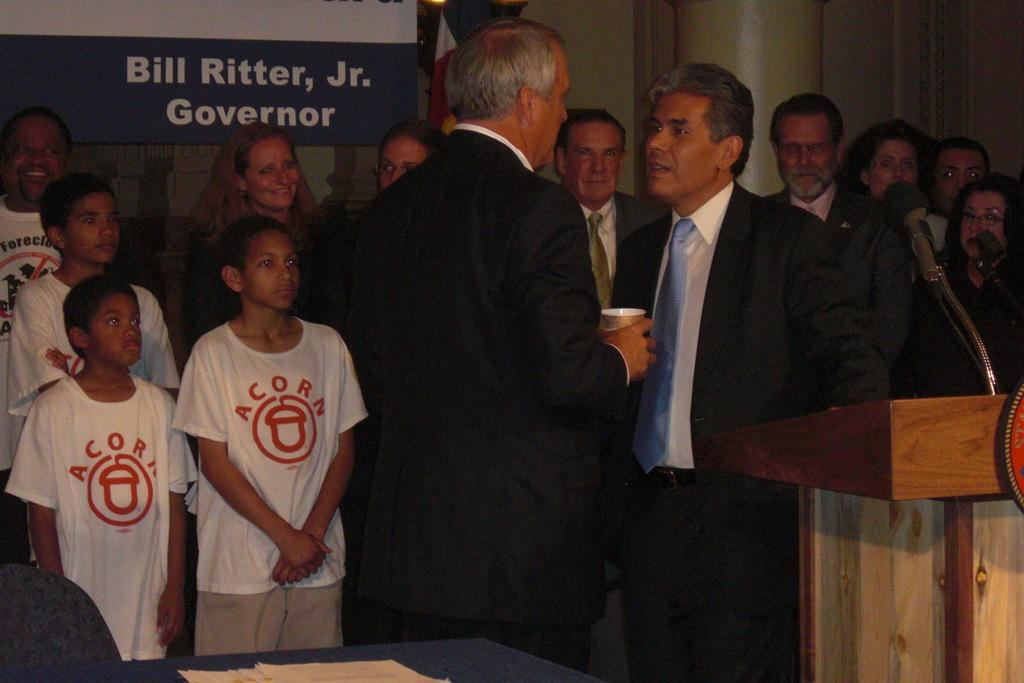<image>
Provide a brief description of the given image. Two men talking in front of a group of people watching who are in front of a sign that says, "Bill Ritter, Jr. Governor". 